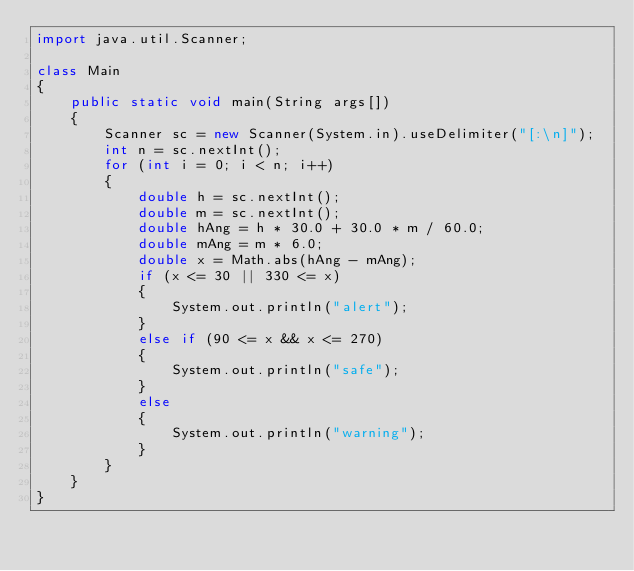Convert code to text. <code><loc_0><loc_0><loc_500><loc_500><_Java_>import java.util.Scanner;

class Main
{
	public static void main(String args[])
	{
		Scanner sc = new Scanner(System.in).useDelimiter("[:\n]");
		int n = sc.nextInt();
		for (int i = 0; i < n; i++)
		{
			double h = sc.nextInt();
			double m = sc.nextInt();
			double hAng = h * 30.0 + 30.0 * m / 60.0;
			double mAng = m * 6.0;
			double x = Math.abs(hAng - mAng);
			if (x <= 30 || 330 <= x)
			{
				System.out.println("alert");
			}
			else if (90 <= x && x <= 270)
			{
				System.out.println("safe");
			}
			else
			{
				System.out.println("warning");
			}
		}
	}
}</code> 